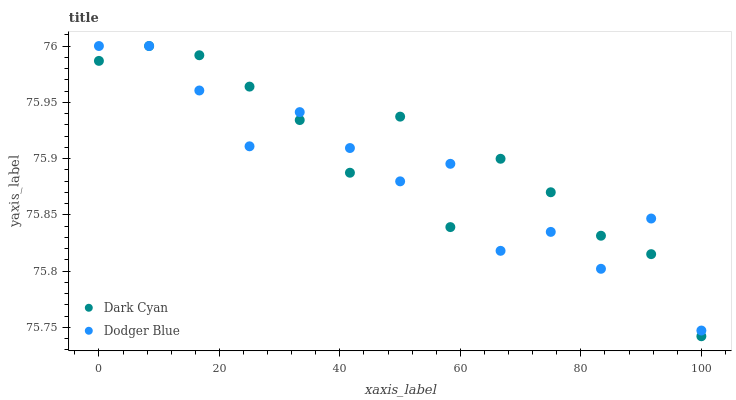Does Dodger Blue have the minimum area under the curve?
Answer yes or no. Yes. Does Dark Cyan have the maximum area under the curve?
Answer yes or no. Yes. Does Dodger Blue have the maximum area under the curve?
Answer yes or no. No. Is Dark Cyan the smoothest?
Answer yes or no. Yes. Is Dodger Blue the roughest?
Answer yes or no. Yes. Is Dodger Blue the smoothest?
Answer yes or no. No. Does Dark Cyan have the lowest value?
Answer yes or no. Yes. Does Dodger Blue have the lowest value?
Answer yes or no. No. Does Dodger Blue have the highest value?
Answer yes or no. Yes. Does Dodger Blue intersect Dark Cyan?
Answer yes or no. Yes. Is Dodger Blue less than Dark Cyan?
Answer yes or no. No. Is Dodger Blue greater than Dark Cyan?
Answer yes or no. No. 